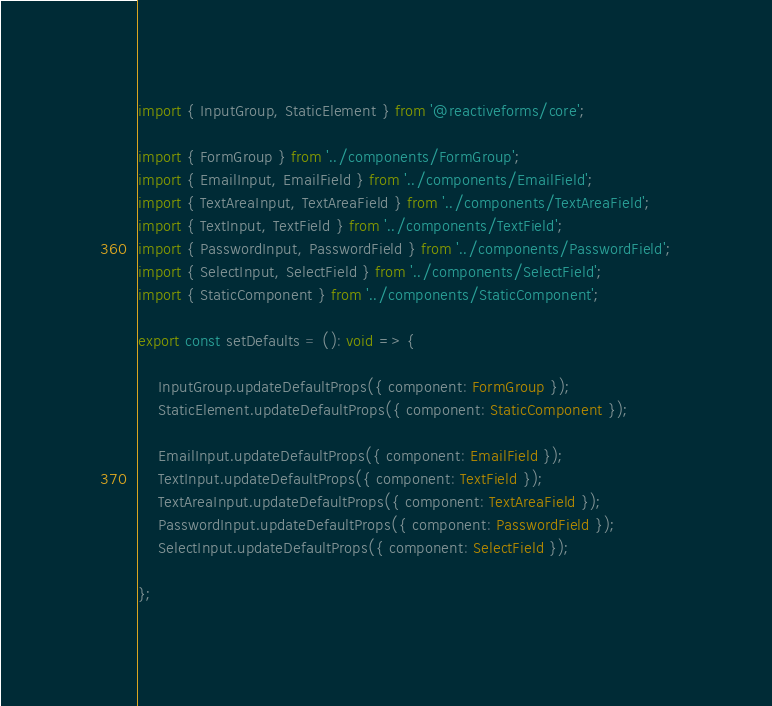Convert code to text. <code><loc_0><loc_0><loc_500><loc_500><_TypeScript_>
import { InputGroup, StaticElement } from '@reactiveforms/core';

import { FormGroup } from '../components/FormGroup';
import { EmailInput, EmailField } from '../components/EmailField';
import { TextAreaInput, TextAreaField } from '../components/TextAreaField';
import { TextInput, TextField } from '../components/TextField';
import { PasswordInput, PasswordField } from '../components/PasswordField';
import { SelectInput, SelectField } from '../components/SelectField';
import { StaticComponent } from '../components/StaticComponent';

export const setDefaults = (): void => {

    InputGroup.updateDefaultProps({ component: FormGroup });
    StaticElement.updateDefaultProps({ component: StaticComponent });

    EmailInput.updateDefaultProps({ component: EmailField });
    TextInput.updateDefaultProps({ component: TextField });
    TextAreaInput.updateDefaultProps({ component: TextAreaField });
    PasswordInput.updateDefaultProps({ component: PasswordField });
    SelectInput.updateDefaultProps({ component: SelectField });

};
</code> 